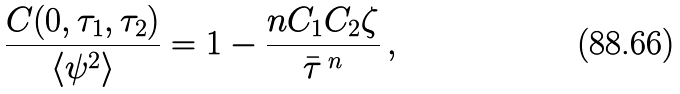<formula> <loc_0><loc_0><loc_500><loc_500>\frac { C ( { 0 } , \tau _ { 1 } , \tau _ { 2 } ) } { \langle \psi ^ { 2 } \rangle } = 1 - \frac { n C _ { 1 } C _ { 2 } \zeta } { \bar { \tau } \, ^ { n } } \, ,</formula> 